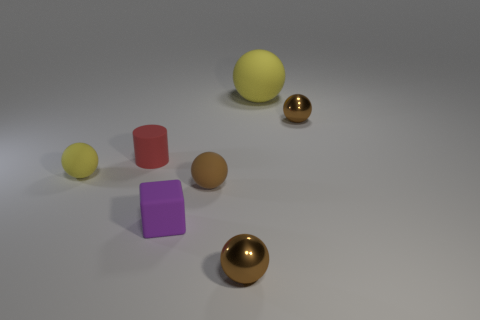How many objects are either objects that are to the left of the purple cube or tiny brown shiny spheres?
Offer a very short reply. 4. There is another tiny rubber thing that is the same shape as the tiny brown rubber object; what is its color?
Your response must be concise. Yellow. Is there any other thing that is the same color as the tiny matte cylinder?
Provide a short and direct response. No. How big is the brown thing behind the tiny red object?
Provide a short and direct response. Small. There is a big object; does it have the same color as the small matte ball that is on the left side of the cube?
Your response must be concise. Yes. What number of other things are there of the same material as the red cylinder
Give a very brief answer. 4. Is the number of small yellow rubber balls greater than the number of cyan metal things?
Your response must be concise. Yes. There is a ball on the left side of the tiny block; does it have the same color as the large thing?
Make the answer very short. Yes. What color is the rubber cylinder?
Offer a very short reply. Red. There is a yellow sphere that is right of the purple thing; are there any tiny red rubber objects in front of it?
Offer a terse response. Yes. 